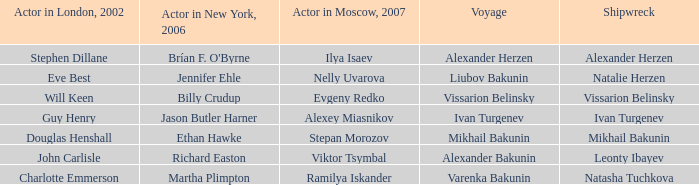Who was the actor in London in 2002 with the shipwreck of Leonty Ibayev? John Carlisle. 